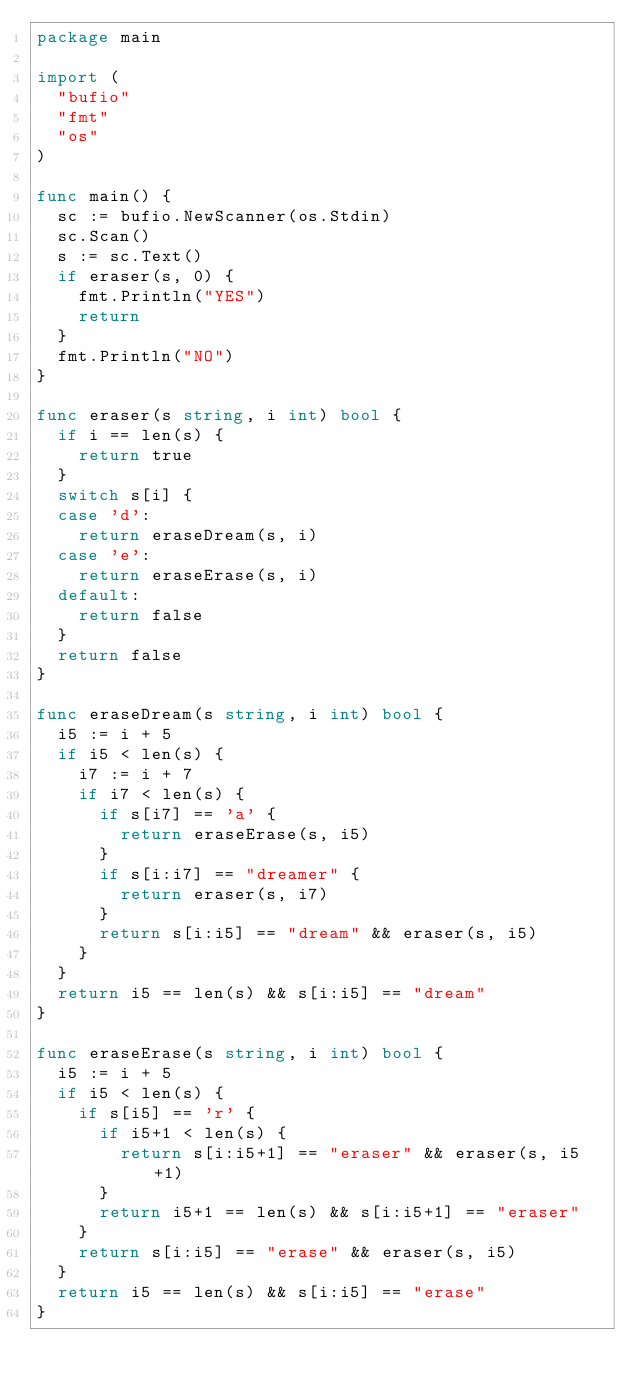Convert code to text. <code><loc_0><loc_0><loc_500><loc_500><_Go_>package main

import (
	"bufio"
	"fmt"
	"os"
)

func main() {
	sc := bufio.NewScanner(os.Stdin)
	sc.Scan()
	s := sc.Text()
	if eraser(s, 0) {
		fmt.Println("YES")
		return
	}
	fmt.Println("NO")
}

func eraser(s string, i int) bool {
	if i == len(s) {
		return true
	}
	switch s[i] {
	case 'd':
		return eraseDream(s, i)
	case 'e':
		return eraseErase(s, i)
	default:
		return false
	}
	return false
}

func eraseDream(s string, i int) bool {
	i5 := i + 5
	if i5 < len(s) {
		i7 := i + 7
		if i7 < len(s) {
			if s[i7] == 'a' {
				return eraseErase(s, i5)
			}
			if s[i:i7] == "dreamer" {
				return eraser(s, i7)
			}
			return s[i:i5] == "dream" && eraser(s, i5)
		}
	}
	return i5 == len(s) && s[i:i5] == "dream"
}

func eraseErase(s string, i int) bool {
	i5 := i + 5
	if i5 < len(s) {
		if s[i5] == 'r' {
			if i5+1 < len(s) {
				return s[i:i5+1] == "eraser" && eraser(s, i5+1)
			}
			return i5+1 == len(s) && s[i:i5+1] == "eraser"
		}
		return s[i:i5] == "erase" && eraser(s, i5)
	}
	return i5 == len(s) && s[i:i5] == "erase"
}
</code> 